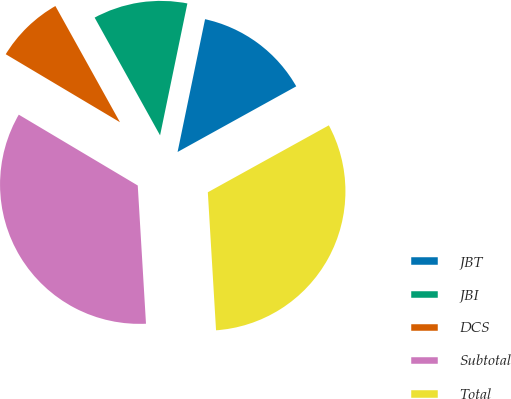<chart> <loc_0><loc_0><loc_500><loc_500><pie_chart><fcel>JBT<fcel>JBI<fcel>DCS<fcel>Subtotal<fcel>Total<nl><fcel>13.71%<fcel>11.32%<fcel>8.38%<fcel>34.49%<fcel>32.09%<nl></chart> 